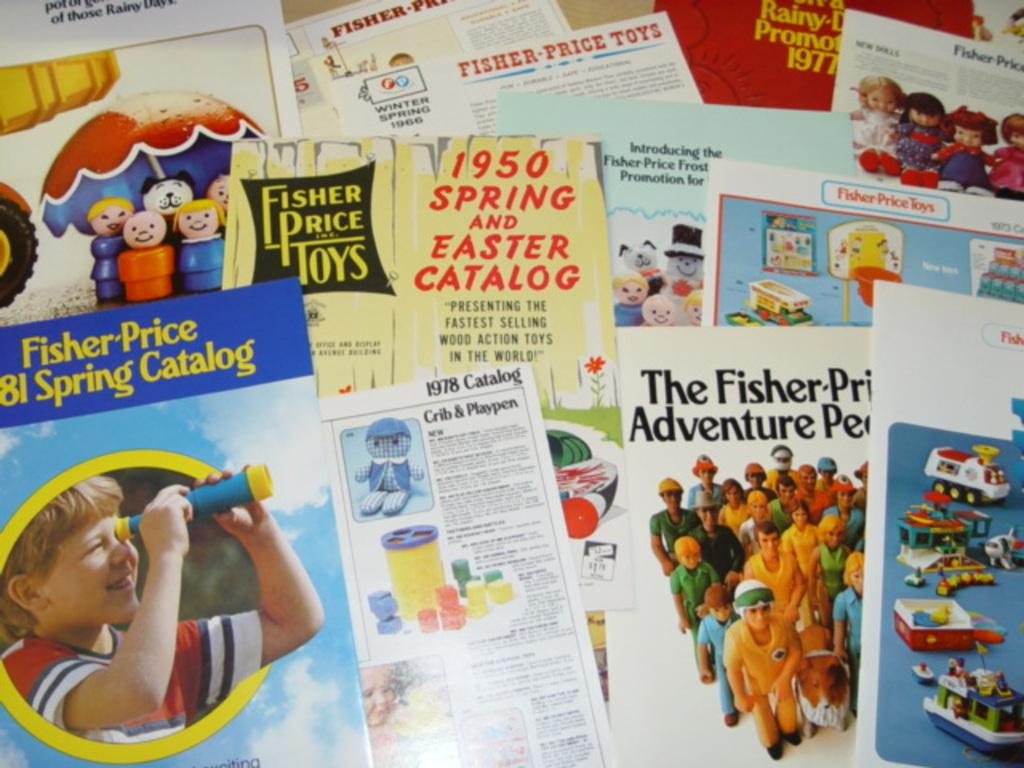What objects are on the platform in the image? There are cards and posters with pictures on the platform. Can you describe the posters with pictures on the platform? The posters with pictures on the platform have images on them. What type of impulse can be seen affecting the cards on the platform? There is no impulse affecting the cards on the platform in the image. What color are the socks worn by the person holding the cards? There is no person holding the cards or wearing socks visible in the image. 